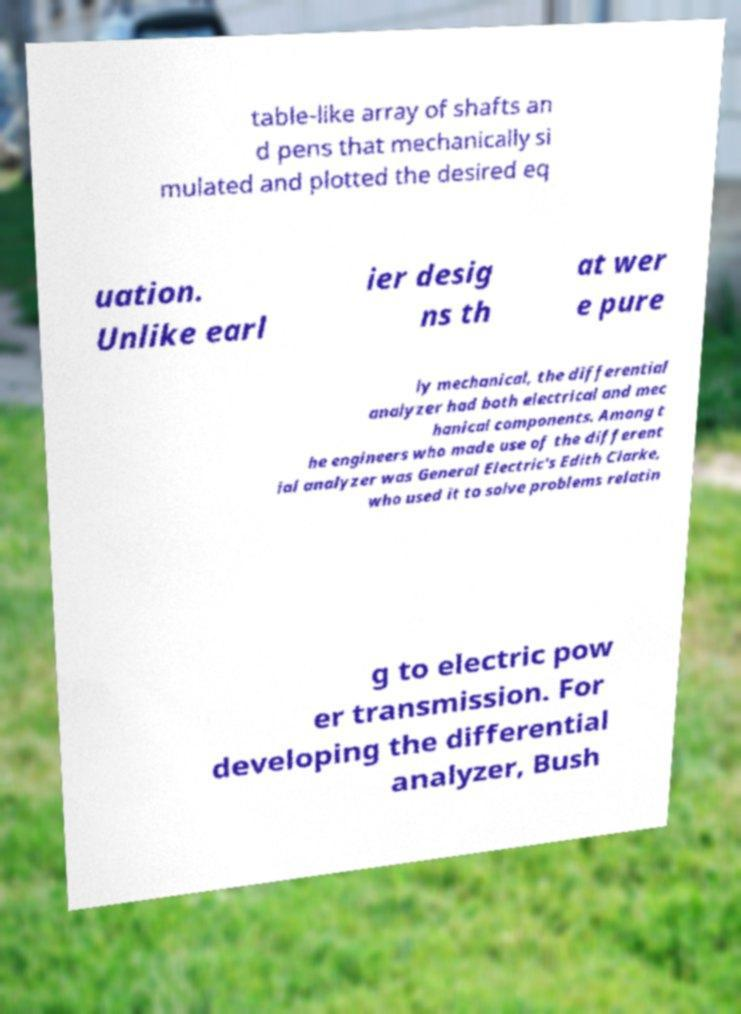Please identify and transcribe the text found in this image. table-like array of shafts an d pens that mechanically si mulated and plotted the desired eq uation. Unlike earl ier desig ns th at wer e pure ly mechanical, the differential analyzer had both electrical and mec hanical components. Among t he engineers who made use of the different ial analyzer was General Electric's Edith Clarke, who used it to solve problems relatin g to electric pow er transmission. For developing the differential analyzer, Bush 